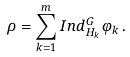<formula> <loc_0><loc_0><loc_500><loc_500>\rho = \sum _ { k = 1 } ^ { m } I n d _ { H _ { k } } ^ { G } \varphi _ { k } \, .</formula> 